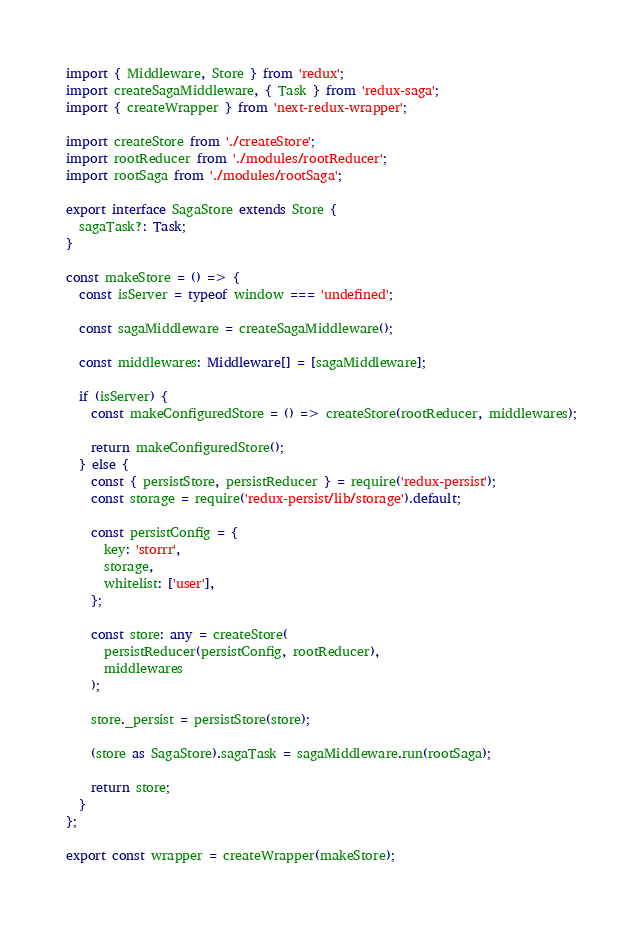Convert code to text. <code><loc_0><loc_0><loc_500><loc_500><_TypeScript_>import { Middleware, Store } from 'redux';
import createSagaMiddleware, { Task } from 'redux-saga';
import { createWrapper } from 'next-redux-wrapper';

import createStore from './createStore';
import rootReducer from './modules/rootReducer';
import rootSaga from './modules/rootSaga';

export interface SagaStore extends Store {
  sagaTask?: Task;
}

const makeStore = () => {
  const isServer = typeof window === 'undefined';

  const sagaMiddleware = createSagaMiddleware();

  const middlewares: Middleware[] = [sagaMiddleware];

  if (isServer) {
    const makeConfiguredStore = () => createStore(rootReducer, middlewares);

    return makeConfiguredStore();
  } else {
    const { persistStore, persistReducer } = require('redux-persist');
    const storage = require('redux-persist/lib/storage').default;

    const persistConfig = {
      key: 'storrr',
      storage,
      whitelist: ['user'],
    };

    const store: any = createStore(
      persistReducer(persistConfig, rootReducer),
      middlewares
    );

    store._persist = persistStore(store);

    (store as SagaStore).sagaTask = sagaMiddleware.run(rootSaga);

    return store;
  }
};

export const wrapper = createWrapper(makeStore);
</code> 